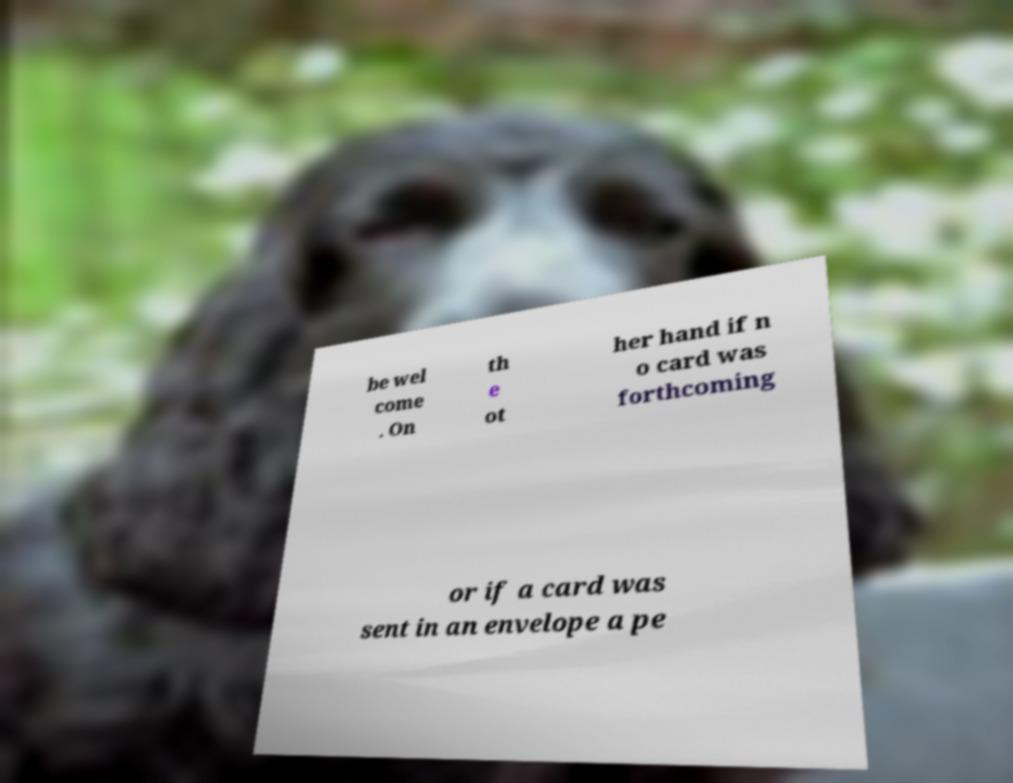Could you assist in decoding the text presented in this image and type it out clearly? be wel come . On th e ot her hand if n o card was forthcoming or if a card was sent in an envelope a pe 